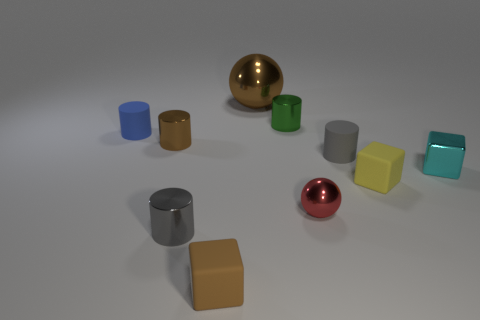There is a ball that is behind the matte thing behind the tiny brown shiny thing; what number of things are in front of it?
Ensure brevity in your answer.  9. Does the matte block that is behind the small brown rubber block have the same color as the metallic cylinder that is in front of the gray rubber object?
Ensure brevity in your answer.  No. Is there anything else that is the same color as the tiny shiny ball?
Keep it short and to the point. No. There is a small matte cube to the right of the block that is to the left of the large brown metallic object; what is its color?
Make the answer very short. Yellow. Are there any large cyan matte blocks?
Ensure brevity in your answer.  No. There is a tiny rubber object that is both left of the brown sphere and behind the small metal sphere; what color is it?
Offer a terse response. Blue. There is a rubber cylinder left of the tiny brown metallic cylinder; does it have the same size as the matte cylinder that is right of the large shiny sphere?
Provide a short and direct response. Yes. What number of other objects are the same size as the yellow rubber object?
Your response must be concise. 8. How many small red metal things are on the right side of the small gray object right of the green object?
Provide a succinct answer. 0. Are there fewer tiny green shiny objects that are in front of the tiny brown metal cylinder than blue rubber cylinders?
Give a very brief answer. Yes. 